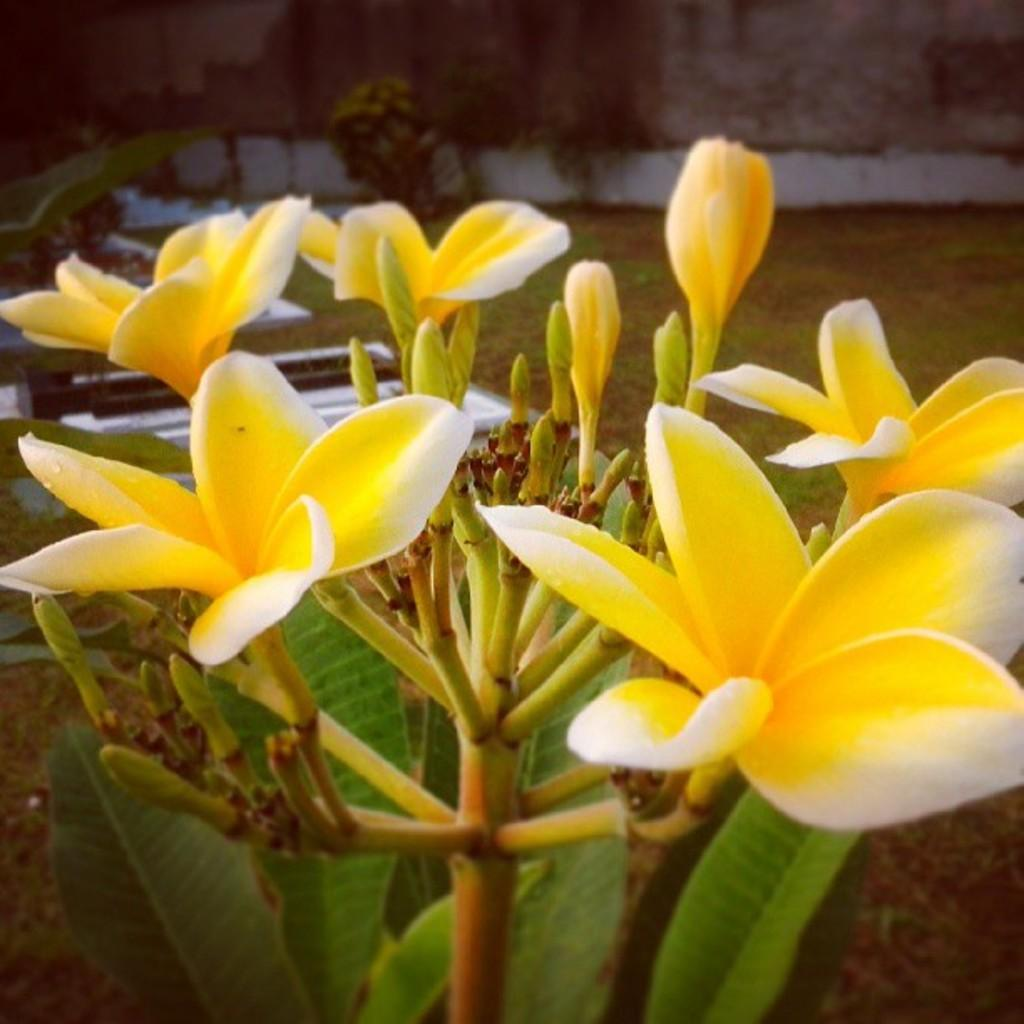What is located in the center of the image? There are flowers and leaves in the center of the image. Can you describe the main elements in the center of the image? The main elements in the center of the image are flowers and leaves. What is visible in the background of the image? There is a wall in the background of the image. What type of screw is being advertised in the image? There is no screw or advertisement present in the image; it features flowers and leaves in the center and a wall in the background. 